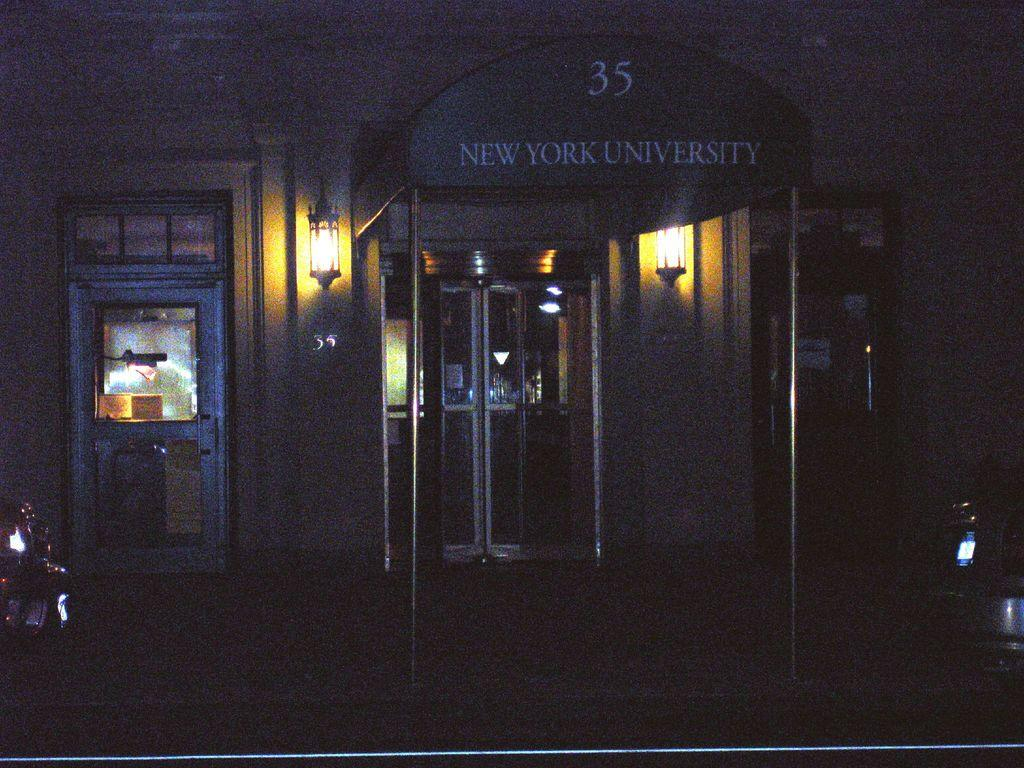What is present on top of the structure in the image? There is a roof in the image. What can be seen on the roof? There is text on the roof. How many doors are visible behind the roof? There are three doors behind the roof. What is attached to the wall between the doors? There are two lamps fixed to the wall between the doors. Where is the sink located in the image? There is no sink present in the image. What type of coil can be seen wrapped around the lamps in the image? There are no coils visible in the image, and the lamps are not wrapped around anything. 